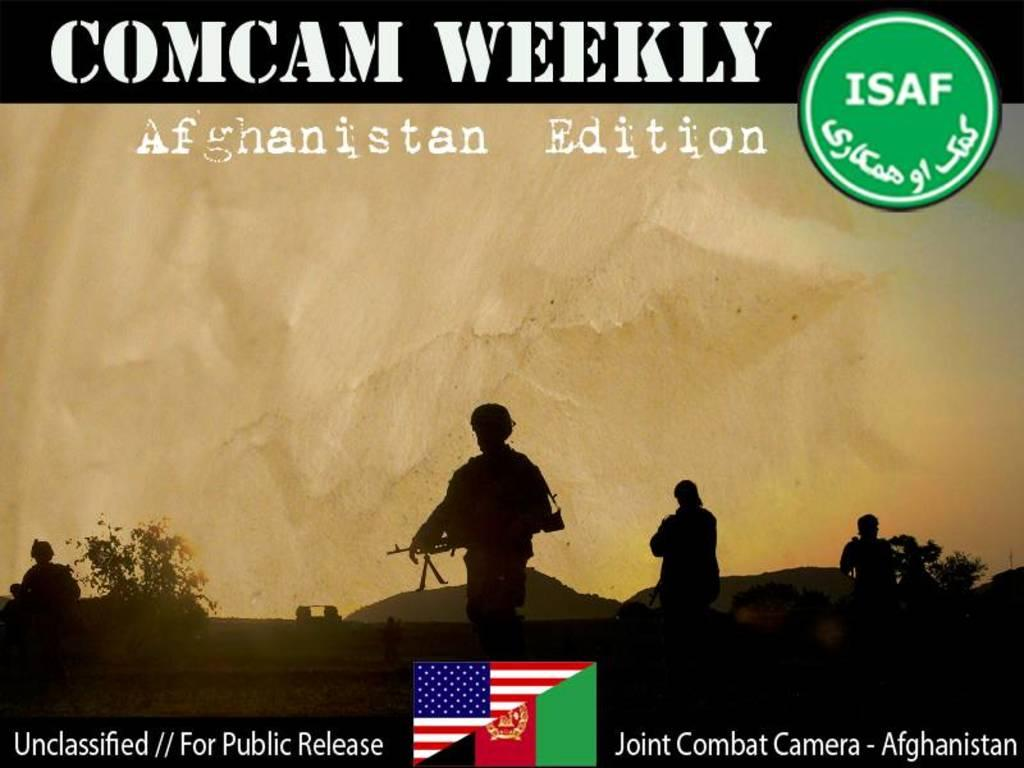<image>
Describe the image concisely. The cover of Comcam Weekly Afghanistan Edition depicting soldiers. 